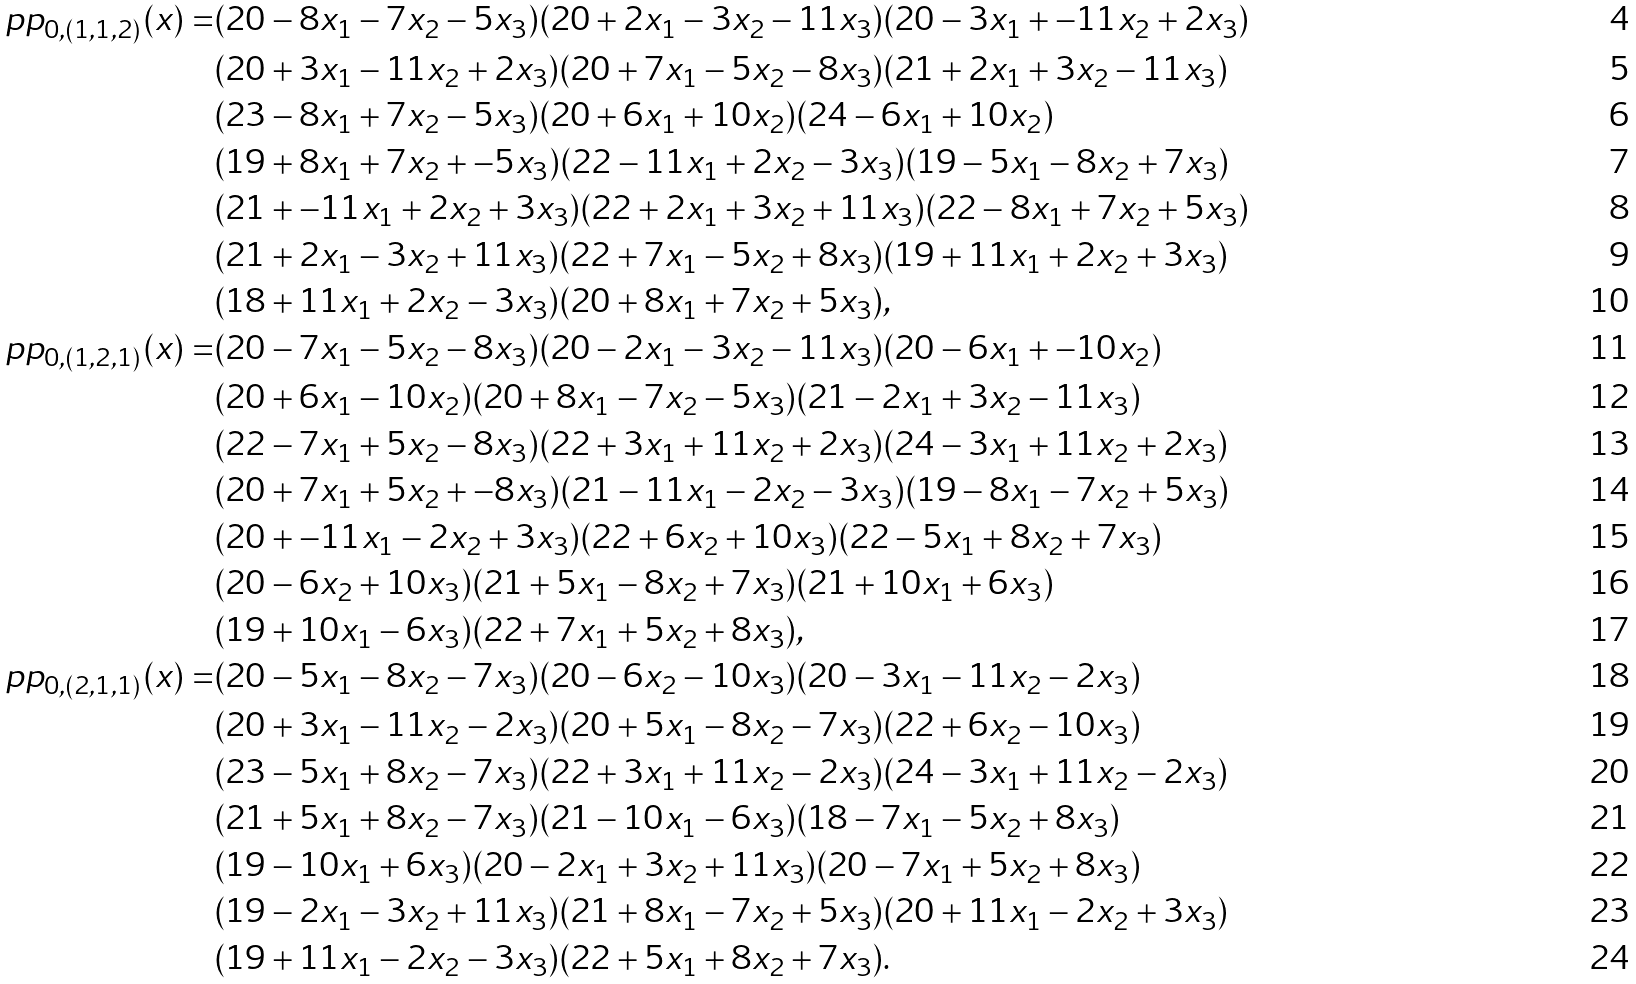Convert formula to latex. <formula><loc_0><loc_0><loc_500><loc_500>\ p p _ { 0 , ( 1 , 1 , 2 ) } ( x ) = & ( 2 0 - 8 x _ { 1 } - 7 x _ { 2 } - 5 x _ { 3 } ) ( 2 0 + 2 x _ { 1 } - 3 x _ { 2 } - 1 1 x _ { 3 } ) ( 2 0 - 3 x _ { 1 } + - 1 1 x _ { 2 } + 2 x _ { 3 } ) \\ & ( 2 0 + 3 x _ { 1 } - 1 1 x _ { 2 } + 2 x _ { 3 } ) ( 2 0 + 7 x _ { 1 } - 5 x _ { 2 } - 8 x _ { 3 } ) ( 2 1 + 2 x _ { 1 } + 3 x _ { 2 } - 1 1 x _ { 3 } ) \\ & ( 2 3 - 8 x _ { 1 } + 7 x _ { 2 } - 5 x _ { 3 } ) ( 2 0 + 6 x _ { 1 } + 1 0 x _ { 2 } ) ( 2 4 - 6 x _ { 1 } + 1 0 x _ { 2 } ) \\ & ( 1 9 + 8 x _ { 1 } + 7 x _ { 2 } + - 5 x _ { 3 } ) ( 2 2 - 1 1 x _ { 1 } + 2 x _ { 2 } - 3 x _ { 3 } ) ( 1 9 - 5 x _ { 1 } - 8 x _ { 2 } + 7 x _ { 3 } ) \\ & ( 2 1 + - 1 1 x _ { 1 } + 2 x _ { 2 } + 3 x _ { 3 } ) ( 2 2 + 2 x _ { 1 } + 3 x _ { 2 } + 1 1 x _ { 3 } ) ( 2 2 - 8 x _ { 1 } + 7 x _ { 2 } + 5 x _ { 3 } ) \\ & ( 2 1 + 2 x _ { 1 } - 3 x _ { 2 } + 1 1 x _ { 3 } ) ( 2 2 + 7 x _ { 1 } - 5 x _ { 2 } + 8 x _ { 3 } ) ( 1 9 + 1 1 x _ { 1 } + 2 x _ { 2 } + 3 x _ { 3 } ) \\ & ( 1 8 + 1 1 x _ { 1 } + 2 x _ { 2 } - 3 x _ { 3 } ) ( 2 0 + 8 x _ { 1 } + 7 x _ { 2 } + 5 x _ { 3 } ) , \\ \ p p _ { 0 , ( 1 , 2 , 1 ) } ( x ) = & ( 2 0 - 7 x _ { 1 } - 5 x _ { 2 } - 8 x _ { 3 } ) ( 2 0 - 2 x _ { 1 } - 3 x _ { 2 } - 1 1 x _ { 3 } ) ( 2 0 - 6 x _ { 1 } + - 1 0 x _ { 2 } ) \\ & ( 2 0 + 6 x _ { 1 } - 1 0 x _ { 2 } ) ( 2 0 + 8 x _ { 1 } - 7 x _ { 2 } - 5 x _ { 3 } ) ( 2 1 - 2 x _ { 1 } + 3 x _ { 2 } - 1 1 x _ { 3 } ) \\ & ( 2 2 - 7 x _ { 1 } + 5 x _ { 2 } - 8 x _ { 3 } ) ( 2 2 + 3 x _ { 1 } + 1 1 x _ { 2 } + 2 x _ { 3 } ) ( 2 4 - 3 x _ { 1 } + 1 1 x _ { 2 } + 2 x _ { 3 } ) \\ & ( 2 0 + 7 x _ { 1 } + 5 x _ { 2 } + - 8 x _ { 3 } ) ( 2 1 - 1 1 x _ { 1 } - 2 x _ { 2 } - 3 x _ { 3 } ) ( 1 9 - 8 x _ { 1 } - 7 x _ { 2 } + 5 x _ { 3 } ) \\ & ( 2 0 + - 1 1 x _ { 1 } - 2 x _ { 2 } + 3 x _ { 3 } ) ( 2 2 + 6 x _ { 2 } + 1 0 x _ { 3 } ) ( 2 2 - 5 x _ { 1 } + 8 x _ { 2 } + 7 x _ { 3 } ) \\ & ( 2 0 - 6 x _ { 2 } + 1 0 x _ { 3 } ) ( 2 1 + 5 x _ { 1 } - 8 x _ { 2 } + 7 x _ { 3 } ) ( 2 1 + 1 0 x _ { 1 } + 6 x _ { 3 } ) \\ & ( 1 9 + 1 0 x _ { 1 } - 6 x _ { 3 } ) ( 2 2 + 7 x _ { 1 } + 5 x _ { 2 } + 8 x _ { 3 } ) , \\ \ p p _ { 0 , ( 2 , 1 , 1 ) } ( x ) = & ( 2 0 - 5 x _ { 1 } - 8 x _ { 2 } - 7 x _ { 3 } ) ( 2 0 - 6 x _ { 2 } - 1 0 x _ { 3 } ) ( 2 0 - 3 x _ { 1 } - 1 1 x _ { 2 } - 2 x _ { 3 } ) \\ & ( 2 0 + 3 x _ { 1 } - 1 1 x _ { 2 } - 2 x _ { 3 } ) ( 2 0 + 5 x _ { 1 } - 8 x _ { 2 } - 7 x _ { 3 } ) ( 2 2 + 6 x _ { 2 } - 1 0 x _ { 3 } ) \\ & ( 2 3 - 5 x _ { 1 } + 8 x _ { 2 } - 7 x _ { 3 } ) ( 2 2 + 3 x _ { 1 } + 1 1 x _ { 2 } - 2 x _ { 3 } ) ( 2 4 - 3 x _ { 1 } + 1 1 x _ { 2 } - 2 x _ { 3 } ) \\ & ( 2 1 + 5 x _ { 1 } + 8 x _ { 2 } - 7 x _ { 3 } ) ( 2 1 - 1 0 x _ { 1 } - 6 x _ { 3 } ) ( 1 8 - 7 x _ { 1 } - 5 x _ { 2 } + 8 x _ { 3 } ) \\ & ( 1 9 - 1 0 x _ { 1 } + 6 x _ { 3 } ) ( 2 0 - 2 x _ { 1 } + 3 x _ { 2 } + 1 1 x _ { 3 } ) ( 2 0 - 7 x _ { 1 } + 5 x _ { 2 } + 8 x _ { 3 } ) \\ & ( 1 9 - 2 x _ { 1 } - 3 x _ { 2 } + 1 1 x _ { 3 } ) ( 2 1 + 8 x _ { 1 } - 7 x _ { 2 } + 5 x _ { 3 } ) ( 2 0 + 1 1 x _ { 1 } - 2 x _ { 2 } + 3 x _ { 3 } ) \\ & ( 1 9 + 1 1 x _ { 1 } - 2 x _ { 2 } - 3 x _ { 3 } ) ( 2 2 + 5 x _ { 1 } + 8 x _ { 2 } + 7 x _ { 3 } ) .</formula> 